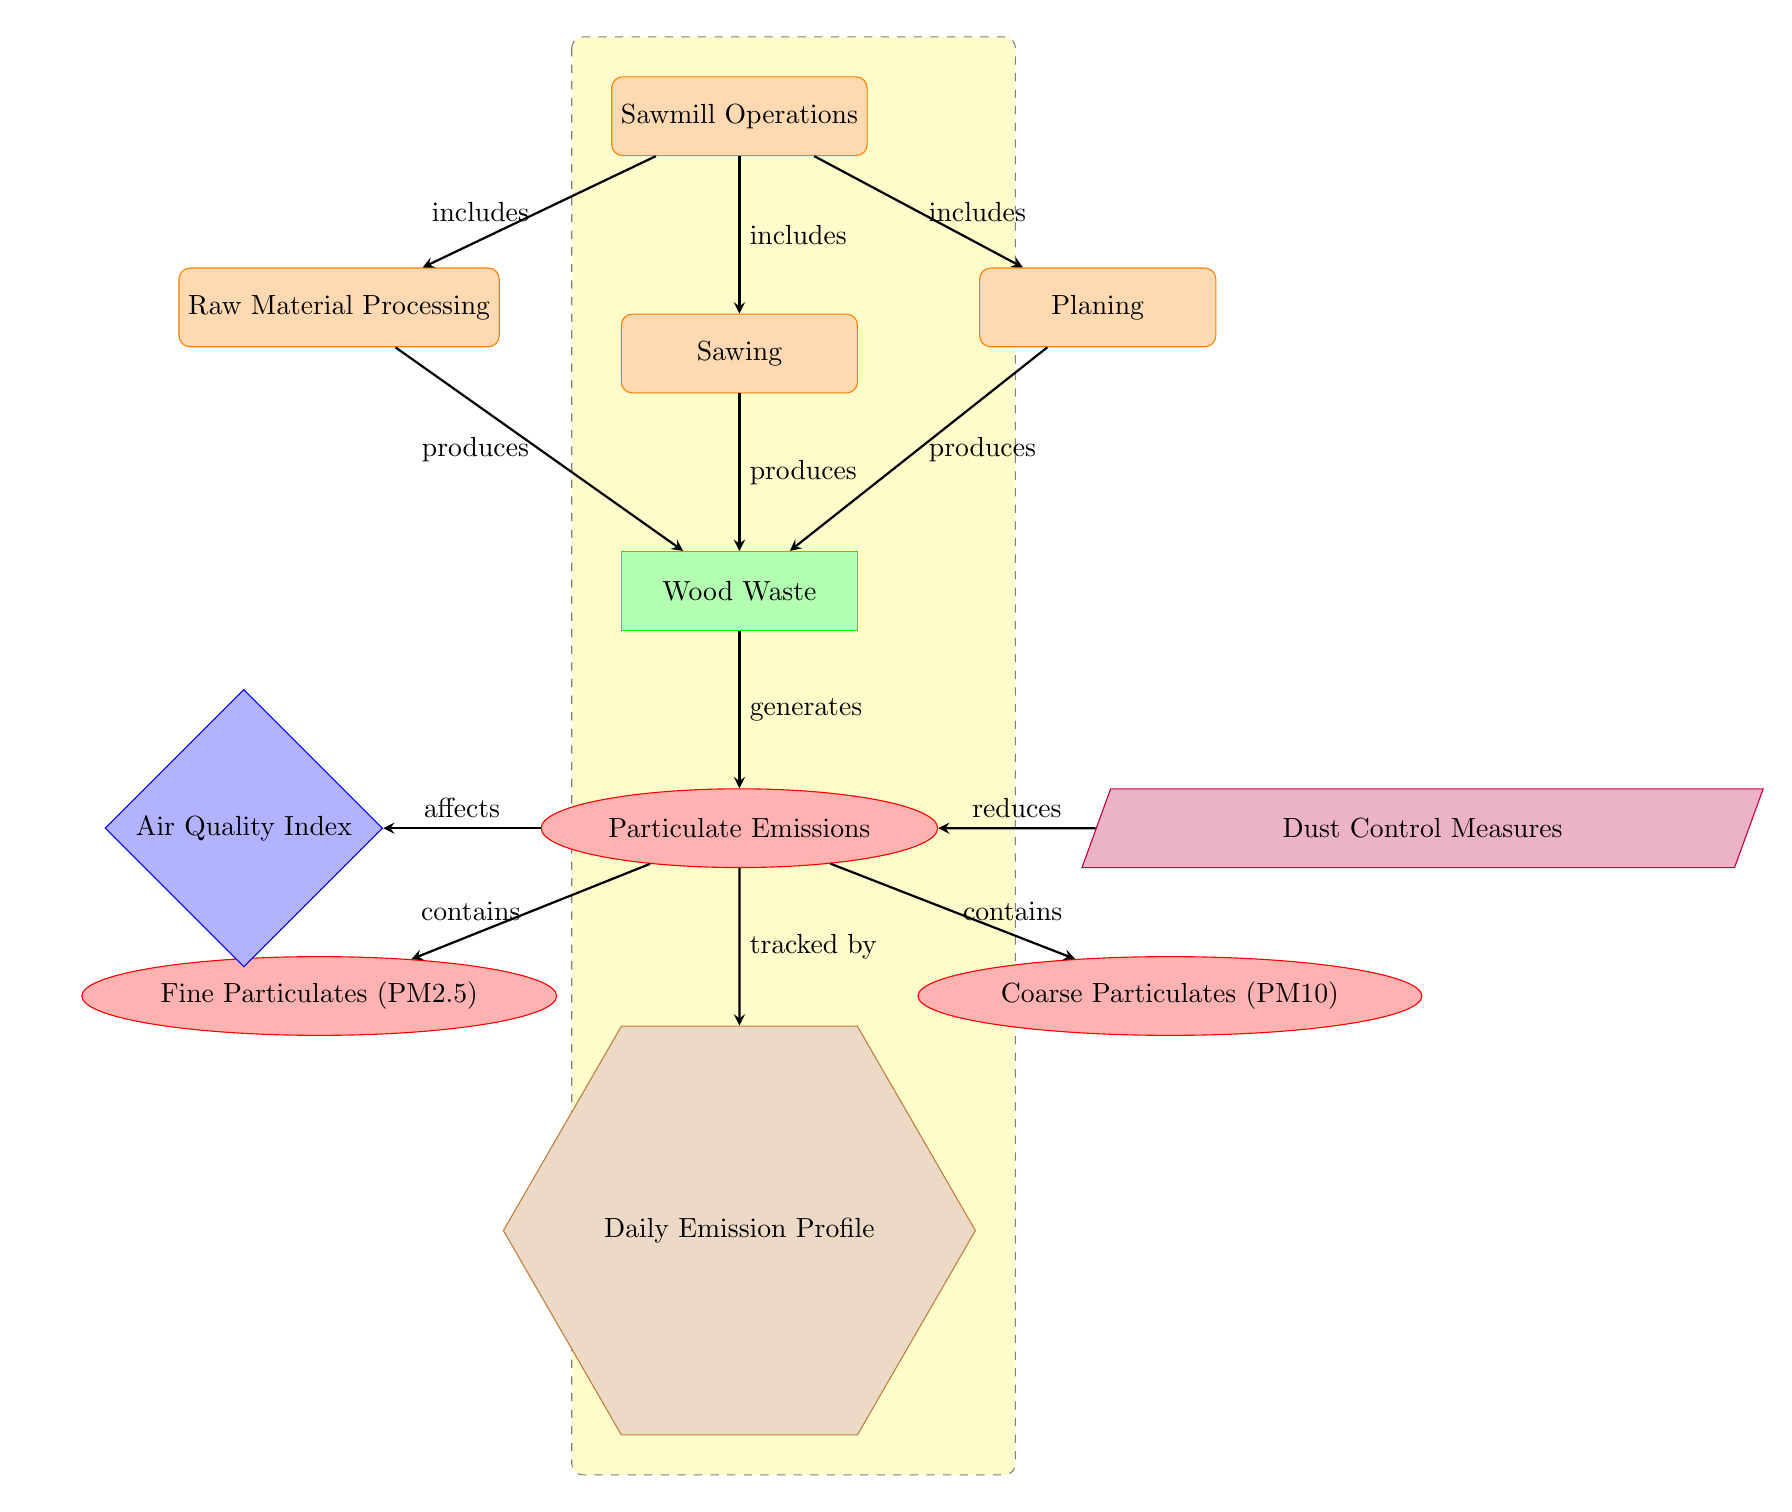What is the process involved in the diagram? The diagram identifies 'Sawmill Operations' as the main process at the top, which includes three sub-processes: 'Raw Material Processing', 'Sawing', and 'Planing'.
Answer: Sawmill Operations How many types of particulate emissions are shown? The diagram displays two types of particulate emissions stemming from the 'Particulate Emissions' node: 'Fine Particulates (PM2.5)' and 'Coarse Particulates (PM10)'.
Answer: Two What does the 'Dust Control Measures' do? In the diagram, 'Dust Control Measures' is connected to 'Particulate Emissions' with an arrow labeled 'reduces', indicating it functions to mitigate emissions.
Answer: Reduces Which node affects the 'Air Quality Index'? The diagram illustrates that 'Particulate Emissions' affects the 'Air Quality Index', as shown by the arrow labeled 'affects' pointing from 'Particulate Emissions' to 'Air Quality Index'.
Answer: Particulate Emissions What do the arrows represent in the diagram? The arrows in the diagram signify the relationships or flow of information between different nodes, indicating processes, production, containment, or effects.
Answer: Relationships 